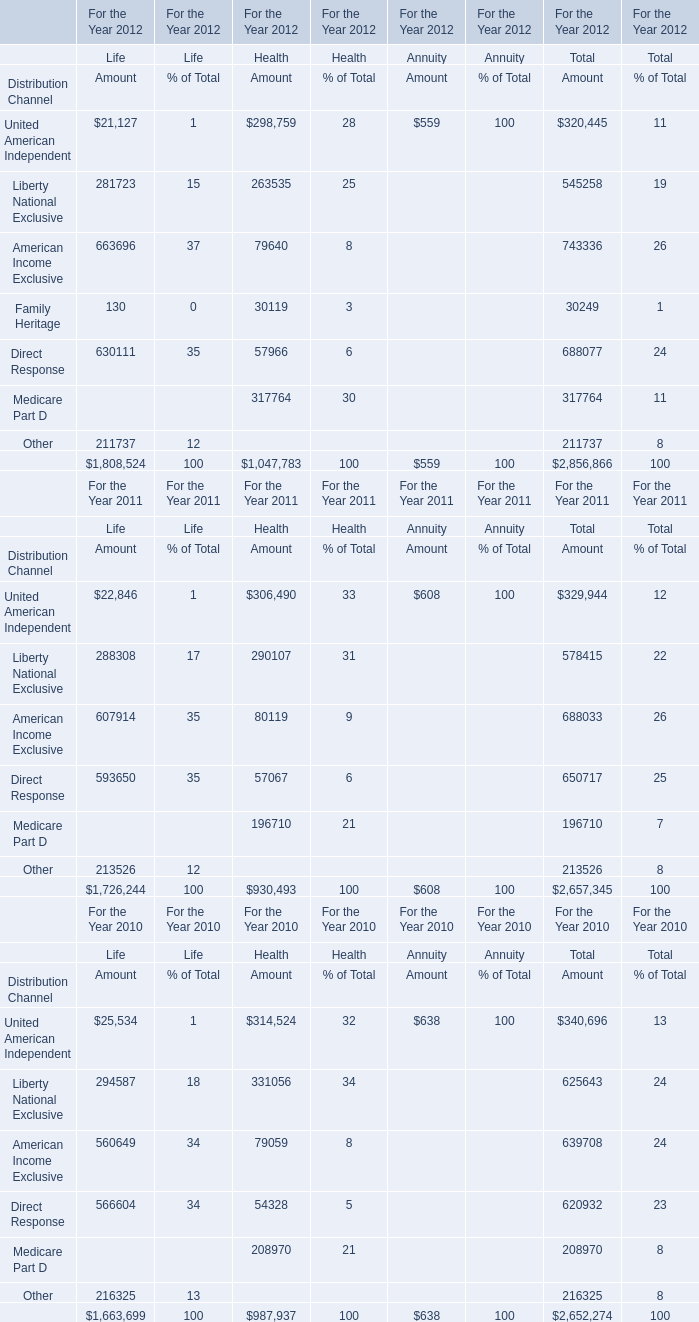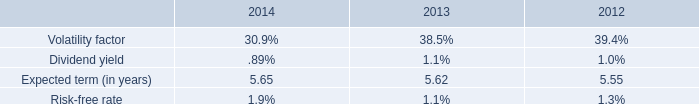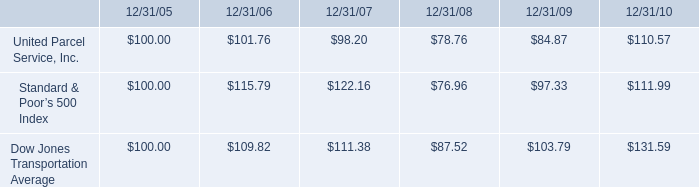Which year is American Income Exclusive for Health the highest? 
Answer: 2011. In the year with largest amount of American Income Exclusive for Health, what's the increasing rate of Liberty National Exclusive for Health? 
Computations: ((290107 - 331056) / 331056)
Answer: -0.12369. 